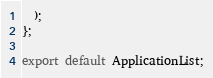Convert code to text. <code><loc_0><loc_0><loc_500><loc_500><_TypeScript_>  );
};

export default ApplicationList;</code> 